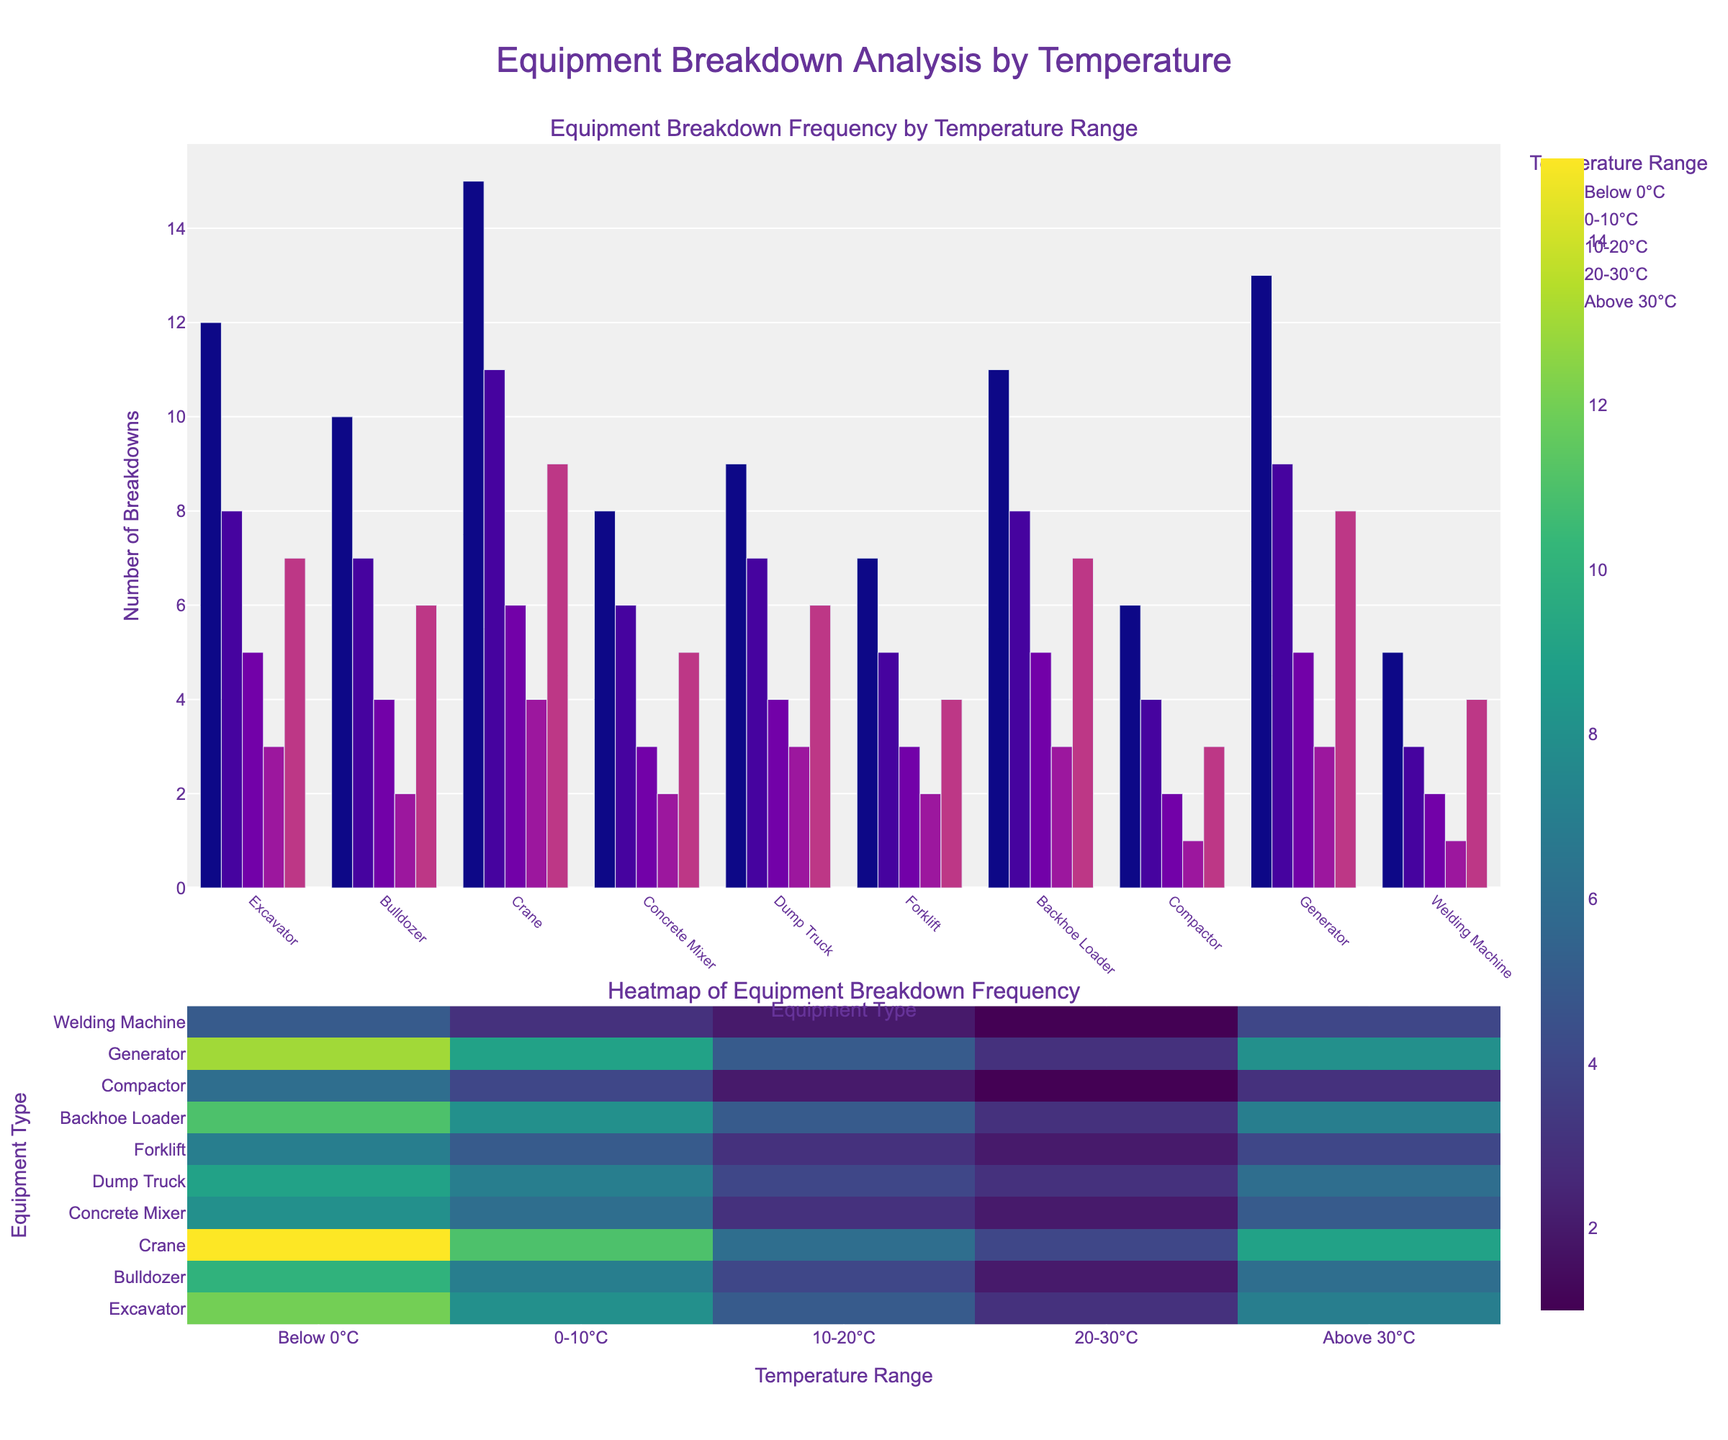Which equipment type has the highest total number of breakdowns across all temperature ranges? To find the equipment with the highest total breakdowns, sum the breakdowns across all temperature ranges for each equipment type. The Excavator has 12 + 8 + 5 + 3 + 7 = 35; Bulldozer has 29; Crane has 45; Concrete Mixer has 24; Dump Truck has 29; Forklift has 21; Backhoe Loader has 34; Compactor has 16; Generator has 38; Welding Machine has 15. The Crane has the highest total with 45 breakdowns.
Answer: Crane At which temperature range does the Crane experience the most breakdowns? Look at the breakdown data for the Crane across all temperature ranges: Below 0°C = 15, 0-10°C = 11, 10-20°C = 6, 20-30°C = 4, Above 30°C = 9. The highest value is 15, which falls in the Below 0°C range.
Answer: Below 0°C How many breakdowns occur for all equipment combined in the 10-20°C range? Sum the breakdowns for the 10-20°C range across all equipment types: Excavator = 5, Bulldozer = 4, Crane = 6, Concrete Mixer = 3, Dump Truck = 4, Forklift = 3, Backhoe Loader = 5, Compactor = 2, Generator = 5, Welding Machine = 2. The total is 5 + 4 + 6 + 3 + 4 + 3 + 5 + 2 + 5 + 2 = 39.
Answer: 39 Which temperature range shows the least frequent breakdowns for the Backhoe Loader? Examine the breakdown data for the Backhoe Loader across all temperature ranges: Below 0°C = 11, 0-10°C = 8, 10-20°C = 5, 20-30°C = 3, Above 30°C = 7. The lowest value is 3, occurring in the 20-30°C range.
Answer: 20-30°C Compare the breakdown frequency of the Excavator and Bulldozer in the 0-10°C range. Which equipment has more breakdowns and by how many? The breakdowns for Excavator in the 0-10°C range = 8; for Bulldozer = 7. The Excavator has 1 more breakdown than the Bulldozer in this range.
Answer: Excavator, by 1 What is the average breakdown frequency for the Forklift across all temperature ranges? Sum the breakdowns for the Forklift across all temperature ranges: 7 + 5 + 3 + 2 + 4 = 21. There are 5 temperature ranges, so the average is 21/5 = 4.2.
Answer: 4.2 Which equipment has more breakdowns in the 'Above 30°C' range: Generator or Welding Machine? The breakdowns for Generator in the 'Above 30°C' range = 8; for Welding Machine = 4. The Generator has more breakdowns than the Welding Machine in this range.
Answer: Generator How many more breakdowns does the Crane have compared to the Concrete Mixer in the 'Below 0°C' temperature range? The breakdowns for Crane in 'Below 0°C' = 15; for Concrete Mixer = 8. The Crane has 15 - 8 = 7 more breakdowns compared to the Concrete Mixer in this temperature range.
Answer: 7 